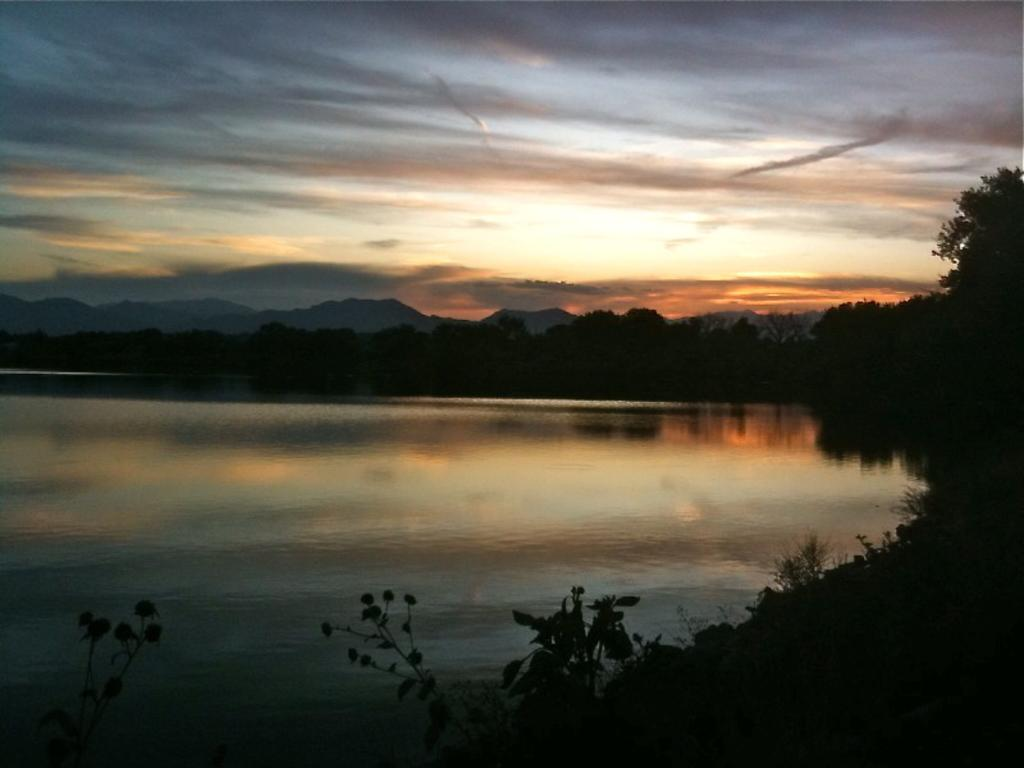What is the main feature of the image? There is a large water body in the image. What else can be seen in the image besides the water body? There is a group of trees and plants in the image. What is visible in the background of the image? There are hills visible in the background of the image. How would you describe the weather in the image? The sky is cloudy in the image. How many children are playing near the water body in the image? There are no children present in the image; it only features a large water body, a group of trees, plants, hills, and a cloudy sky. 